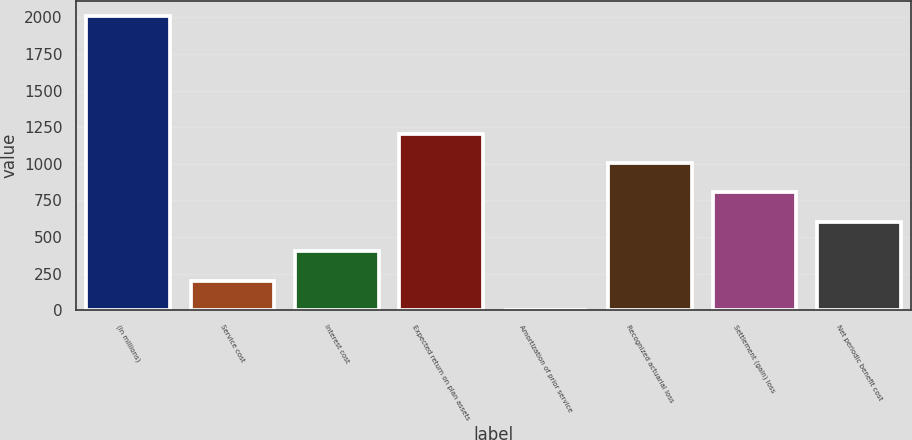Convert chart to OTSL. <chart><loc_0><loc_0><loc_500><loc_500><bar_chart><fcel>(In millions)<fcel>Service cost<fcel>Interest cost<fcel>Expected return on plan assets<fcel>Amortization of prior service<fcel>Recognized actuarial loss<fcel>Settlement (gain) loss<fcel>Net periodic benefit cost<nl><fcel>2011<fcel>201.19<fcel>402.28<fcel>1206.64<fcel>0.1<fcel>1005.55<fcel>804.46<fcel>603.37<nl></chart> 